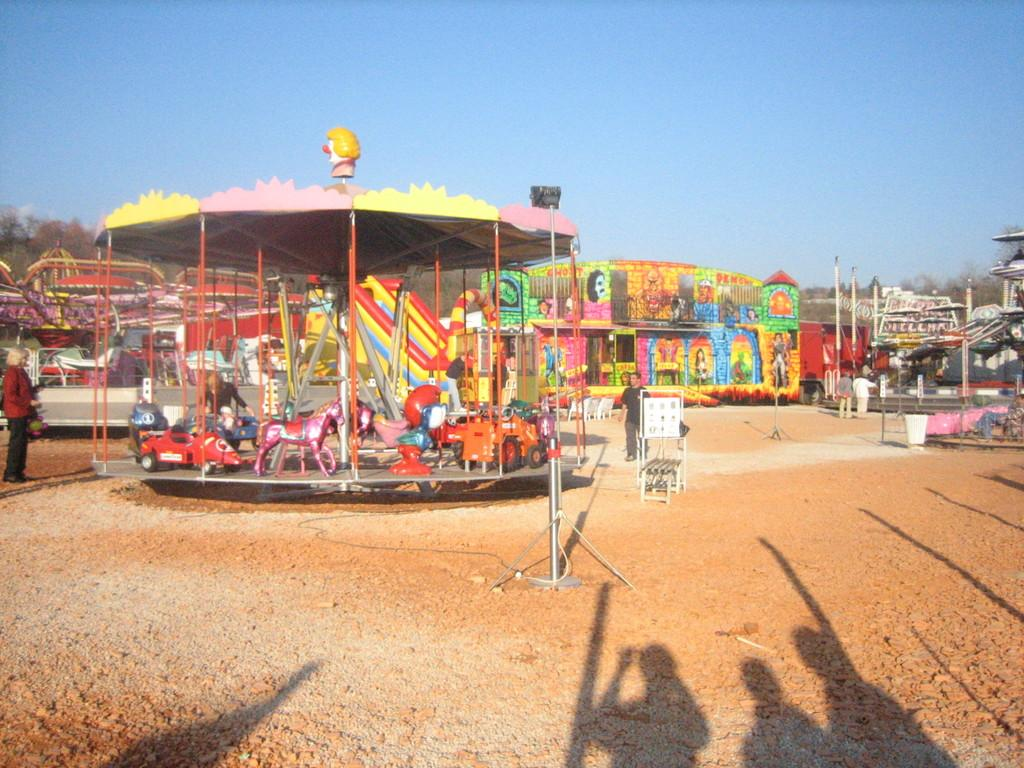What is happening in the image? There is an exhibition in the image. What can be seen on the ground in the image? There are people standing on the ground and metal objects in the image. What is visible in the background of the image? The sky is visible in the background of the image. What type of food is being served at the educational event in the image? There is no mention of food or an educational event in the image; it features an exhibition with people and metal objects on the ground, and the sky visible in the background. 